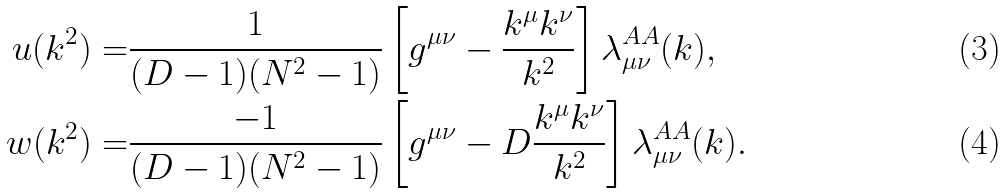<formula> <loc_0><loc_0><loc_500><loc_500>u ( k ^ { 2 } ) = & \frac { 1 } { ( D - 1 ) ( N ^ { 2 } - 1 ) } \left [ g ^ { \mu \nu } - \frac { k ^ { \mu } k ^ { \nu } } { k ^ { 2 } } \right ] \lambda _ { \mu \nu } ^ { A A } ( k ) , \\ w ( k ^ { 2 } ) = & \frac { - 1 } { ( D - 1 ) ( N ^ { 2 } - 1 ) } \left [ g ^ { \mu \nu } - D \frac { k ^ { \mu } k ^ { \nu } } { k ^ { 2 } } \right ] \lambda _ { \mu \nu } ^ { A A } ( k ) .</formula> 